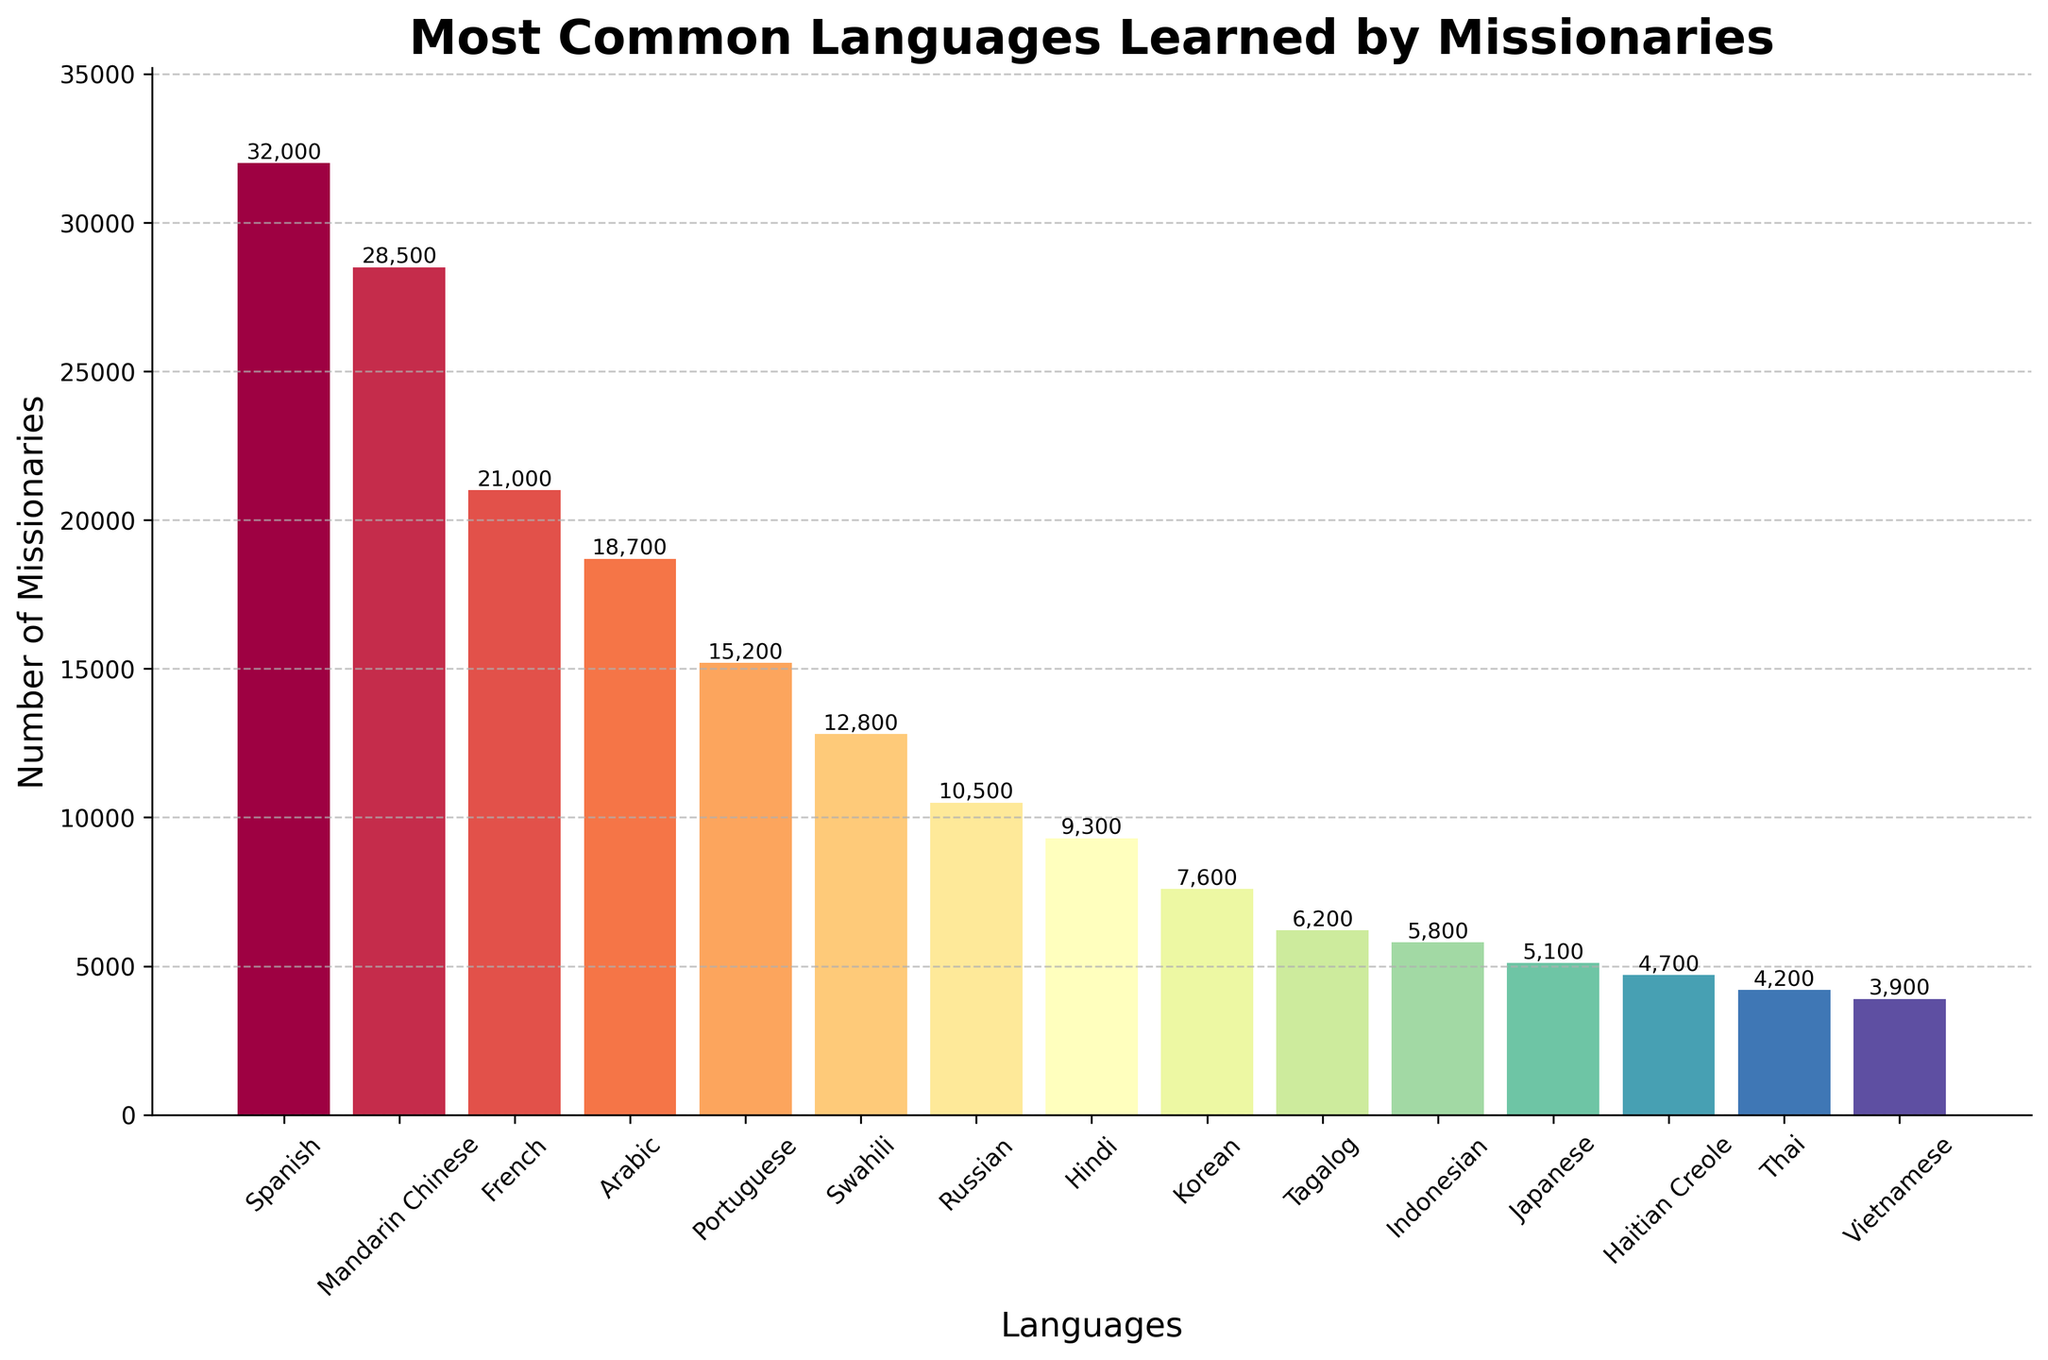Which language is learned by the most missionaries? The bar representing Spanish is the tallest, indicating the highest number of missionaries, with a value of 32,000 missionaries learning it.
Answer: Spanish How many more missionaries learn Spanish than Portuguese? The height of the Spanish bar is 32,000 and the height of the Portuguese bar is 15,200. The difference is calculated as 32,000 - 15,200.
Answer: 16,800 What is the total number of missionaries learning French and Arabic combined? Summing up the heights of the French and Arabic bars, we have 21,000 for French and 18,700 for Arabic. Adding these together: 21,000 + 18,700.
Answer: 39,700 Which language is learned by fewer missionaries, Japanese or Haitian Creole? Comparing the heights of the Japanese and Haitian Creole bars, Japanese has 5,100 missionaries and Haitian Creole has 4,700.
Answer: Haitian Creole Is the number of missionaries learning Mandarin Chinese greater than those learning French and Hindi combined? Mandarin Chinese has 28,500 missionaries. French and Hindi combined have 21,000 + 9,300 = 30,300. 28,500 is less than 30,300.
Answer: No What is the average number of missionaries learning the top three most learned languages? The top three languages are Spanish (32,000), Mandarin Chinese (28,500), and French (21,000). The sum is 32,000 + 28,500 + 21,000 = 81,500. The average is 81,500 / 3.
Answer: 27,167 How many languages have fewer than 10,000 missionaries learning them? Bars representing Russian (10,500), Hindi (9,300), Korean (7,600), Tagalog (6,200), Indonesian (5,800), Japanese (5,100), Haitian Creole (4,700), Thai (4,200), and Vietnamese (3,900) all show fewer than 10,000 missionaries. Counting these bars: 9 languages.
Answer: 9 Which language learned by missionaries is represented by the lightest color in the bar chart? The lightest color correlates with the lowest bar, which is Vietnamese, indicating 3,900 missionaries.
Answer: Vietnamese Is Portuguese learned by more missionaries than Hindi and Korean combined? The number of missionaries learning Portuguese is 15,200. Hindi and Korean combined are 9,300 + 7,600 = 16,900, which is higher than 15,200.
Answer: No 